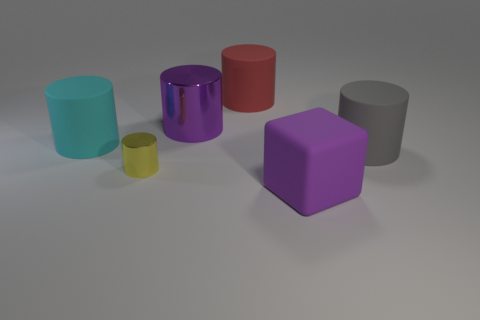Subtract all yellow cylinders. How many cylinders are left? 4 Subtract 1 cylinders. How many cylinders are left? 4 Subtract all red cylinders. How many cylinders are left? 4 Add 2 yellow objects. How many objects exist? 8 Subtract all brown cylinders. Subtract all purple cubes. How many cylinders are left? 5 Subtract all cylinders. How many objects are left? 1 Add 1 yellow cylinders. How many yellow cylinders are left? 2 Add 5 big gray cylinders. How many big gray cylinders exist? 6 Subtract 1 red cylinders. How many objects are left? 5 Subtract all big purple cubes. Subtract all matte blocks. How many objects are left? 4 